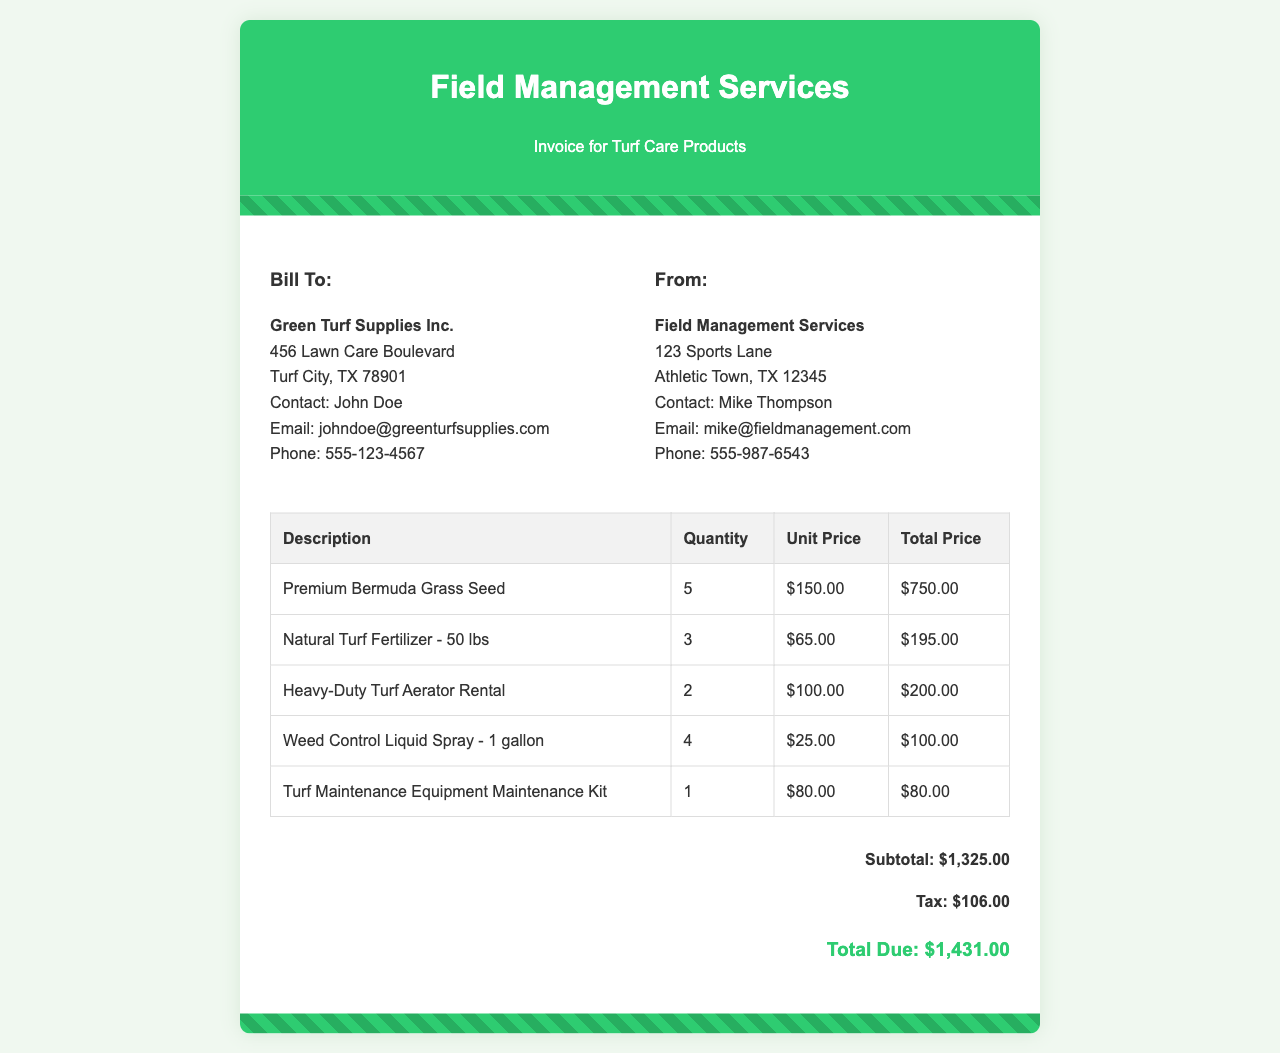what is the total due amount? The total due amount is specified at the bottom of the invoice.
Answer: $1,431.00 who is the contact person for the bill to? The document lists John Doe as the contact for Green Turf Supplies Inc.
Answer: John Doe how many quantities of Premium Bermuda Grass Seed were purchased? The invoice lists the quantity of Premium Bermuda Grass Seed under the description section.
Answer: 5 what is the unit price of Natural Turf Fertilizer - 50 lbs? The unit price for Natural Turf Fertilizer can be found in the corresponding table row.
Answer: $65.00 what is the subtotal before tax? The subtotal is given in the total section of the invoice, before tax is added.
Answer: $1,325.00 which item was rented? The invoice includes a rental entry that specifies which item was rented.
Answer: Heavy-Duty Turf Aerator Rental how many gallons of Weed Control Liquid Spray were ordered? The quantity for Weed Control Liquid Spray is included in the table on the invoice.
Answer: 4 what is the tax amount applied to the invoice? The invoice provides the tax amount in the total section below the subtotal.
Answer: $106.00 who is the sender of this invoice? The sender of the invoice is indicated in the "From:" section at the top of the document.
Answer: Field Management Services 